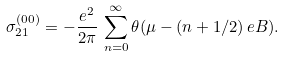Convert formula to latex. <formula><loc_0><loc_0><loc_500><loc_500>\sigma _ { 2 1 } ^ { ( 0 0 ) } = - \frac { e ^ { 2 } } { 2 \pi } \, \sum _ { n = 0 } ^ { \infty } \theta ( \mu - ( n + 1 / 2 ) \, e B ) .</formula> 